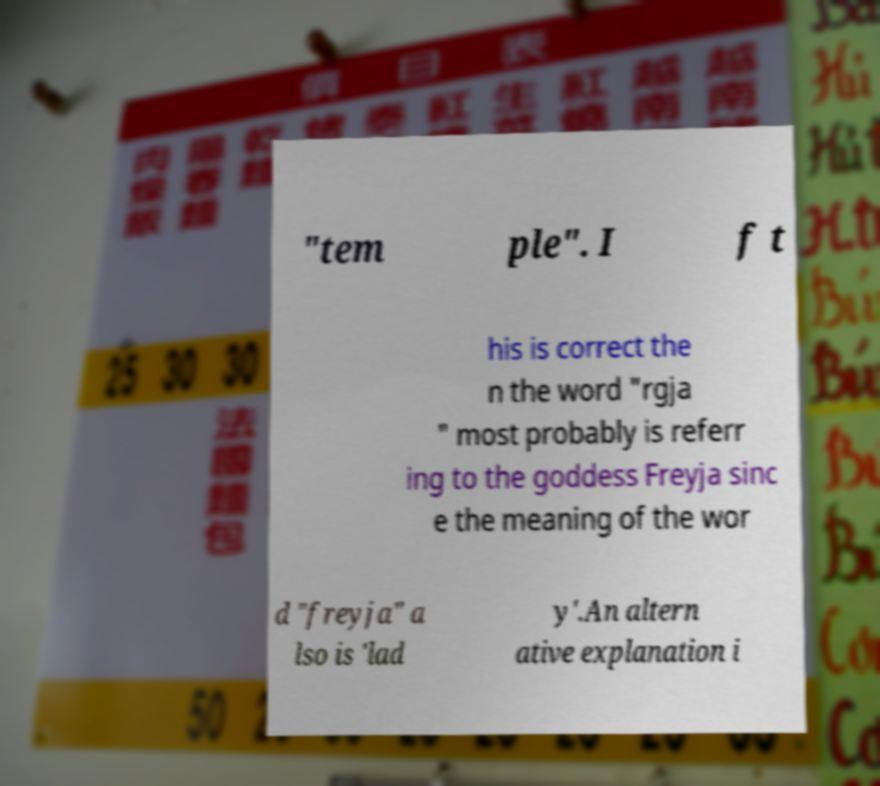There's text embedded in this image that I need extracted. Can you transcribe it verbatim? "tem ple". I f t his is correct the n the word "rgja " most probably is referr ing to the goddess Freyja sinc e the meaning of the wor d "freyja" a lso is 'lad y'.An altern ative explanation i 